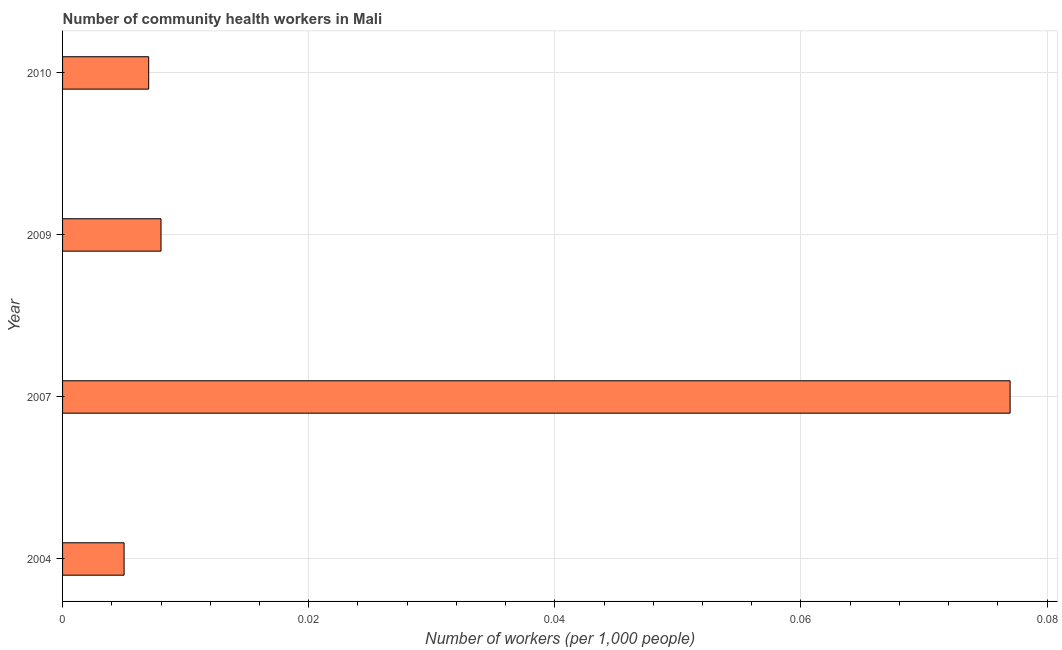Does the graph contain any zero values?
Offer a very short reply. No. Does the graph contain grids?
Provide a succinct answer. Yes. What is the title of the graph?
Your answer should be very brief. Number of community health workers in Mali. What is the label or title of the X-axis?
Give a very brief answer. Number of workers (per 1,0 people). What is the label or title of the Y-axis?
Ensure brevity in your answer.  Year. What is the number of community health workers in 2007?
Offer a terse response. 0.08. Across all years, what is the maximum number of community health workers?
Your answer should be compact. 0.08. Across all years, what is the minimum number of community health workers?
Offer a terse response. 0.01. In which year was the number of community health workers maximum?
Make the answer very short. 2007. In which year was the number of community health workers minimum?
Ensure brevity in your answer.  2004. What is the sum of the number of community health workers?
Your answer should be very brief. 0.1. What is the difference between the number of community health workers in 2007 and 2010?
Ensure brevity in your answer.  0.07. What is the average number of community health workers per year?
Make the answer very short. 0.02. What is the median number of community health workers?
Offer a very short reply. 0.01. In how many years, is the number of community health workers greater than 0.024 ?
Give a very brief answer. 1. Do a majority of the years between 2010 and 2007 (inclusive) have number of community health workers greater than 0.056 ?
Offer a terse response. Yes. What is the ratio of the number of community health workers in 2004 to that in 2009?
Provide a succinct answer. 0.62. Is the number of community health workers in 2004 less than that in 2010?
Provide a succinct answer. Yes. Is the difference between the number of community health workers in 2009 and 2010 greater than the difference between any two years?
Offer a terse response. No. What is the difference between the highest and the second highest number of community health workers?
Ensure brevity in your answer.  0.07. Is the sum of the number of community health workers in 2004 and 2010 greater than the maximum number of community health workers across all years?
Make the answer very short. No. What is the difference between the highest and the lowest number of community health workers?
Ensure brevity in your answer.  0.07. In how many years, is the number of community health workers greater than the average number of community health workers taken over all years?
Provide a succinct answer. 1. How many bars are there?
Your response must be concise. 4. Are the values on the major ticks of X-axis written in scientific E-notation?
Offer a very short reply. No. What is the Number of workers (per 1,000 people) of 2004?
Your answer should be compact. 0.01. What is the Number of workers (per 1,000 people) of 2007?
Make the answer very short. 0.08. What is the Number of workers (per 1,000 people) of 2009?
Provide a short and direct response. 0.01. What is the Number of workers (per 1,000 people) of 2010?
Make the answer very short. 0.01. What is the difference between the Number of workers (per 1,000 people) in 2004 and 2007?
Provide a succinct answer. -0.07. What is the difference between the Number of workers (per 1,000 people) in 2004 and 2009?
Give a very brief answer. -0. What is the difference between the Number of workers (per 1,000 people) in 2004 and 2010?
Give a very brief answer. -0. What is the difference between the Number of workers (per 1,000 people) in 2007 and 2009?
Ensure brevity in your answer.  0.07. What is the difference between the Number of workers (per 1,000 people) in 2007 and 2010?
Give a very brief answer. 0.07. What is the ratio of the Number of workers (per 1,000 people) in 2004 to that in 2007?
Your answer should be very brief. 0.07. What is the ratio of the Number of workers (per 1,000 people) in 2004 to that in 2009?
Offer a terse response. 0.62. What is the ratio of the Number of workers (per 1,000 people) in 2004 to that in 2010?
Give a very brief answer. 0.71. What is the ratio of the Number of workers (per 1,000 people) in 2007 to that in 2009?
Your response must be concise. 9.62. What is the ratio of the Number of workers (per 1,000 people) in 2007 to that in 2010?
Provide a short and direct response. 11. What is the ratio of the Number of workers (per 1,000 people) in 2009 to that in 2010?
Provide a succinct answer. 1.14. 